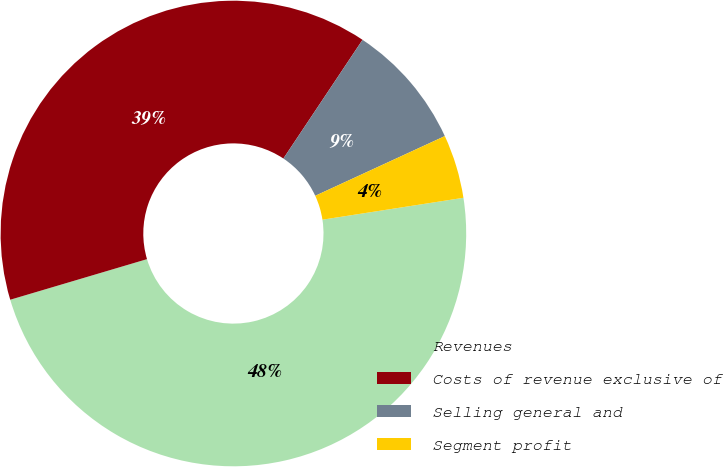Convert chart to OTSL. <chart><loc_0><loc_0><loc_500><loc_500><pie_chart><fcel>Revenues<fcel>Costs of revenue exclusive of<fcel>Selling general and<fcel>Segment profit<nl><fcel>47.86%<fcel>38.95%<fcel>8.77%<fcel>4.42%<nl></chart> 